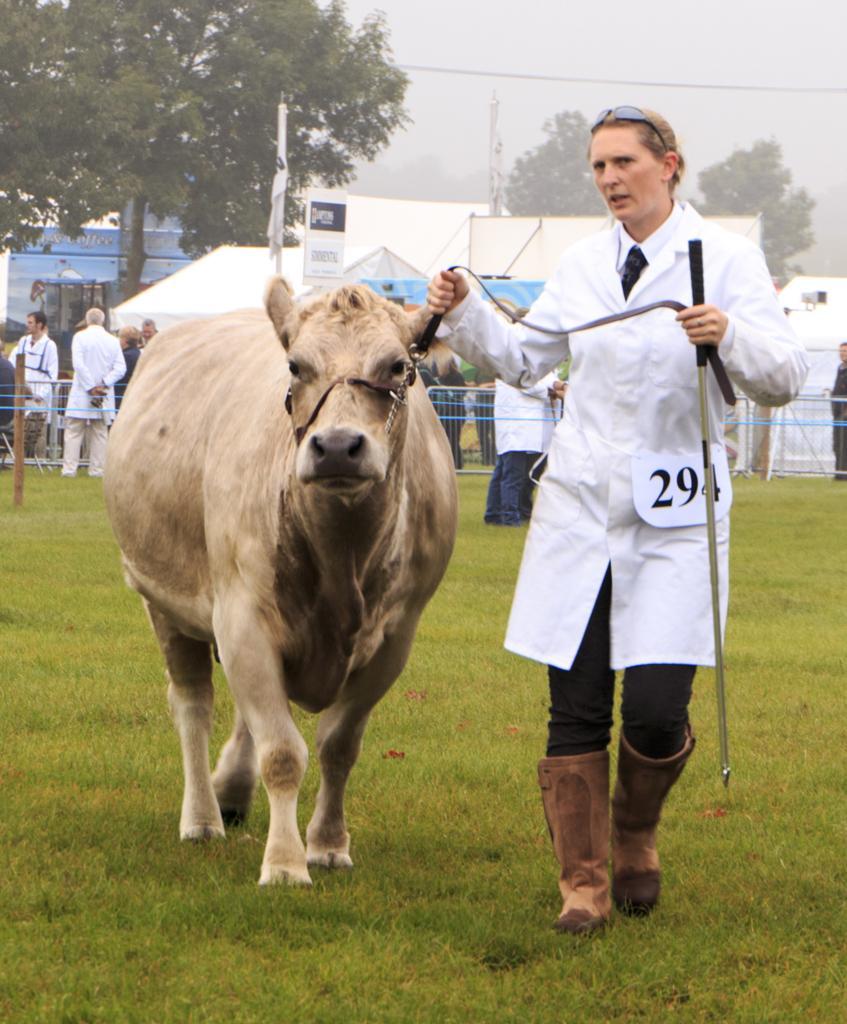Could you give a brief overview of what you see in this image? In this picture we can see a woman holding a cow with a leash in one hand and a stick in another hand. We can see some barricades and few people at the back. There are some tents, flag , board and few poles are visible in the background. 